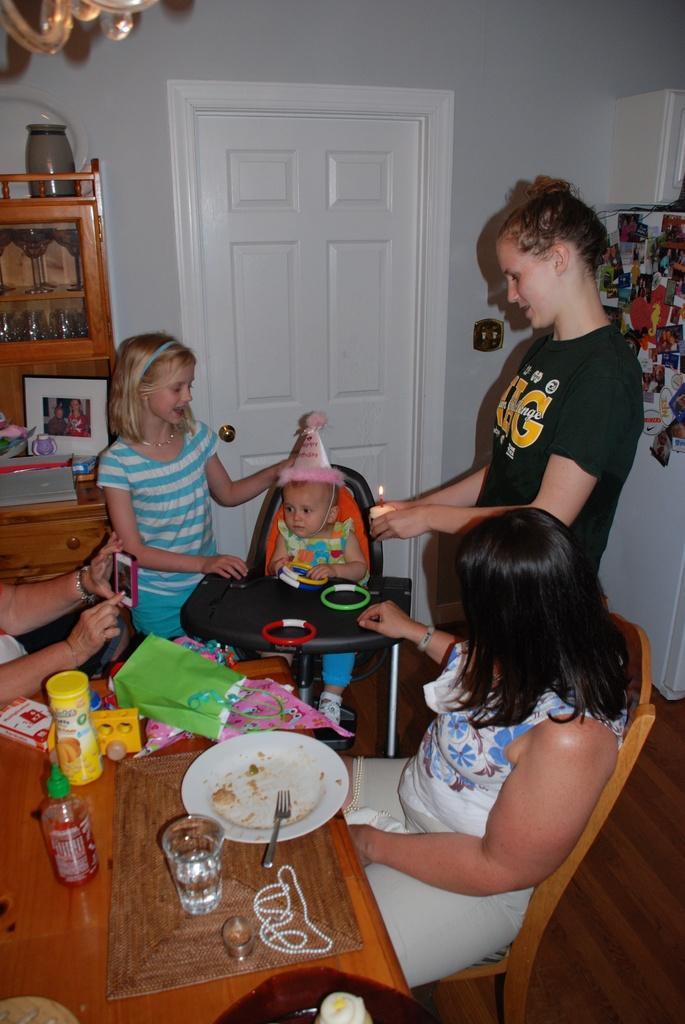In one or two sentences, can you explain what this image depicts? In this picture one women standing here and feeding to the baby and the other girl is standing beside to the baby and one girl is sitting on the chair in front of them there is a table one plate glass of water and they are some eatable things and one person is taking a picture with camera and it look like a room it concessions of door and there are some shelves. 